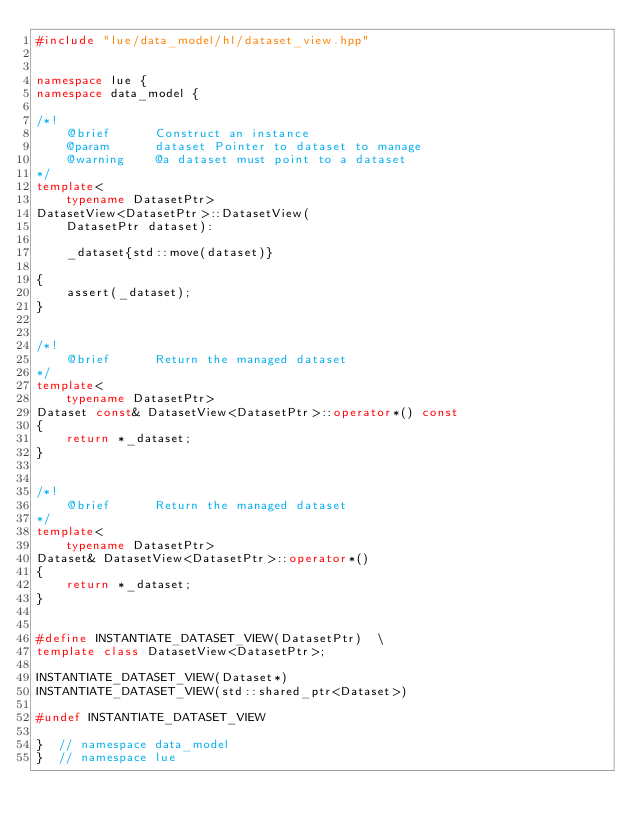Convert code to text. <code><loc_0><loc_0><loc_500><loc_500><_C++_>#include "lue/data_model/hl/dataset_view.hpp"


namespace lue {
namespace data_model {

/*!
    @brief      Construct an instance
    @param      dataset Pointer to dataset to manage
    @warning    @a dataset must point to a dataset
*/
template<
    typename DatasetPtr>
DatasetView<DatasetPtr>::DatasetView(
    DatasetPtr dataset):

    _dataset{std::move(dataset)}

{
    assert(_dataset);
}


/*!
    @brief      Return the managed dataset
*/
template<
    typename DatasetPtr>
Dataset const& DatasetView<DatasetPtr>::operator*() const
{
    return *_dataset;
}


/*!
    @brief      Return the managed dataset
*/
template<
    typename DatasetPtr>
Dataset& DatasetView<DatasetPtr>::operator*()
{
    return *_dataset;
}


#define INSTANTIATE_DATASET_VIEW(DatasetPtr)  \
template class DatasetView<DatasetPtr>;

INSTANTIATE_DATASET_VIEW(Dataset*)
INSTANTIATE_DATASET_VIEW(std::shared_ptr<Dataset>)

#undef INSTANTIATE_DATASET_VIEW

}  // namespace data_model
}  // namespace lue
</code> 